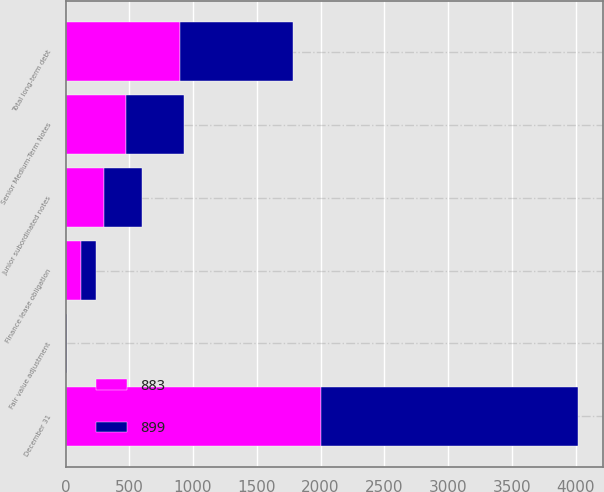Convert chart. <chart><loc_0><loc_0><loc_500><loc_500><stacked_bar_chart><ecel><fcel>December 31<fcel>Senior Medium-Term Notes<fcel>Junior subordinated notes<fcel>Finance lease obligation<fcel>Fair value adjustment<fcel>Total long-term debt<nl><fcel>899<fcel>2008<fcel>458<fcel>300<fcel>116<fcel>9<fcel>883<nl><fcel>883<fcel>2007<fcel>473<fcel>299<fcel>121<fcel>6<fcel>899<nl></chart> 